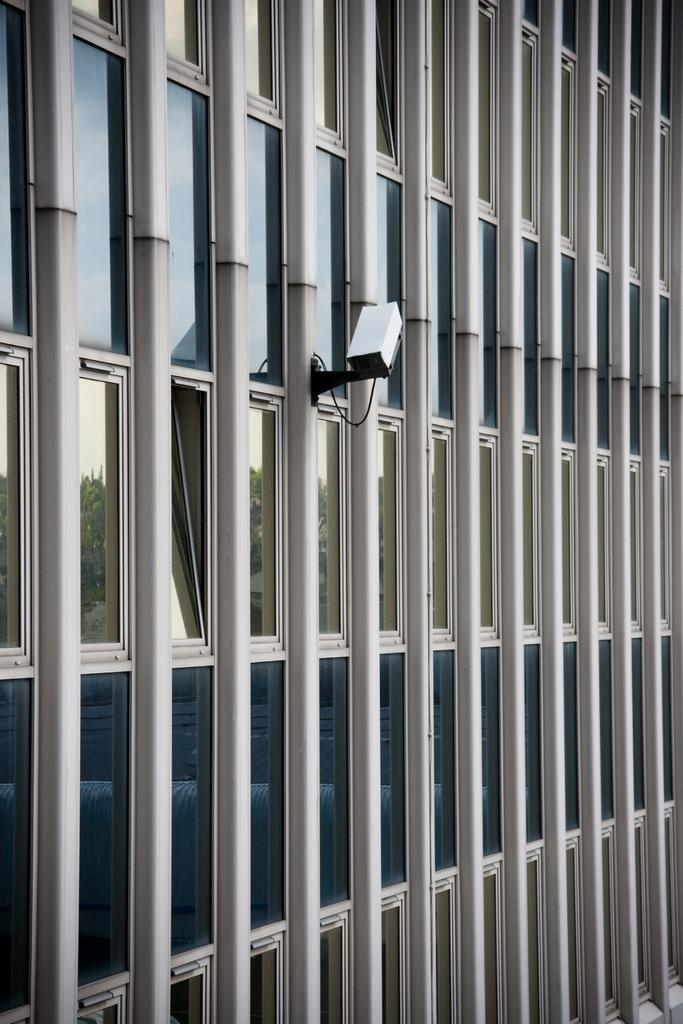What type of structure is present in the image? There is a building in the image. What feature can be observed on the building? The building has glass windows. What device is visible in the image? There is a camera in the image. What natural elements can be seen in the image through the reflection? The reflection of trees and the sky is visible in the image. What type of meat is being cooked in the image? There is no meat or cooking activity present in the image. What stage of development is the building in the image? The building appears to be a completed structure, so it is not in a development stage. 